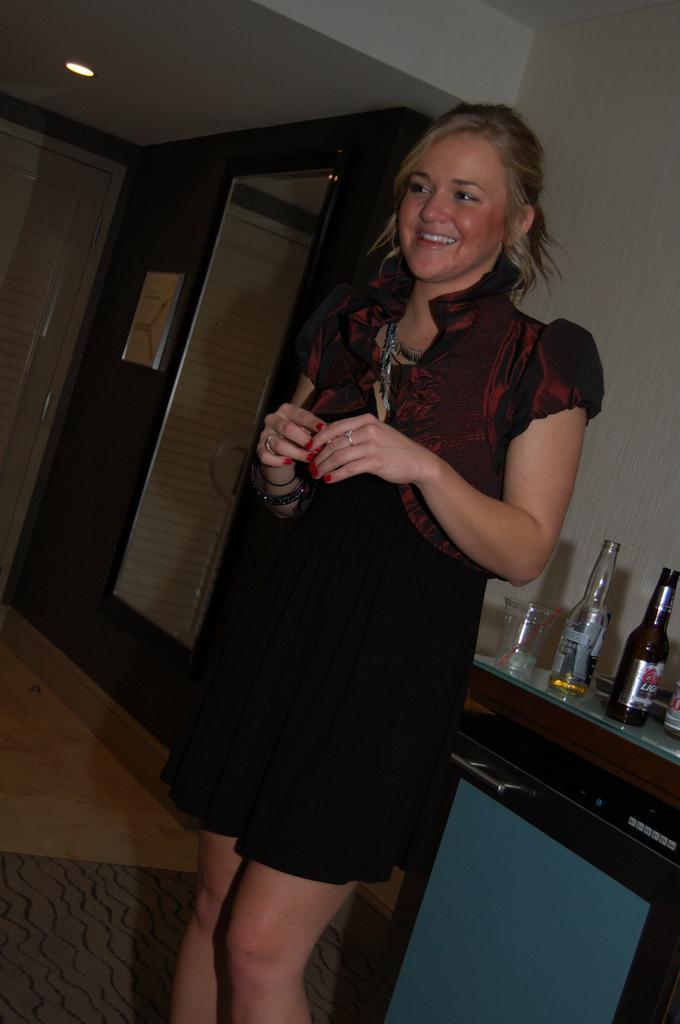How would you summarize this image in a sentence or two? In the image we can see there is a woman who is standing and on table there are wine bottles and a glass. 